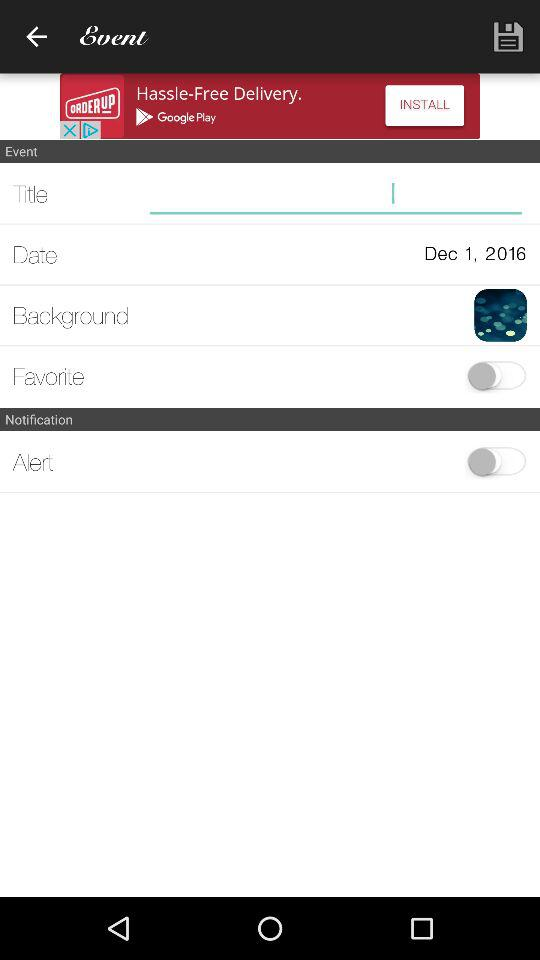What is the status of "Alert"? The status is "off". 